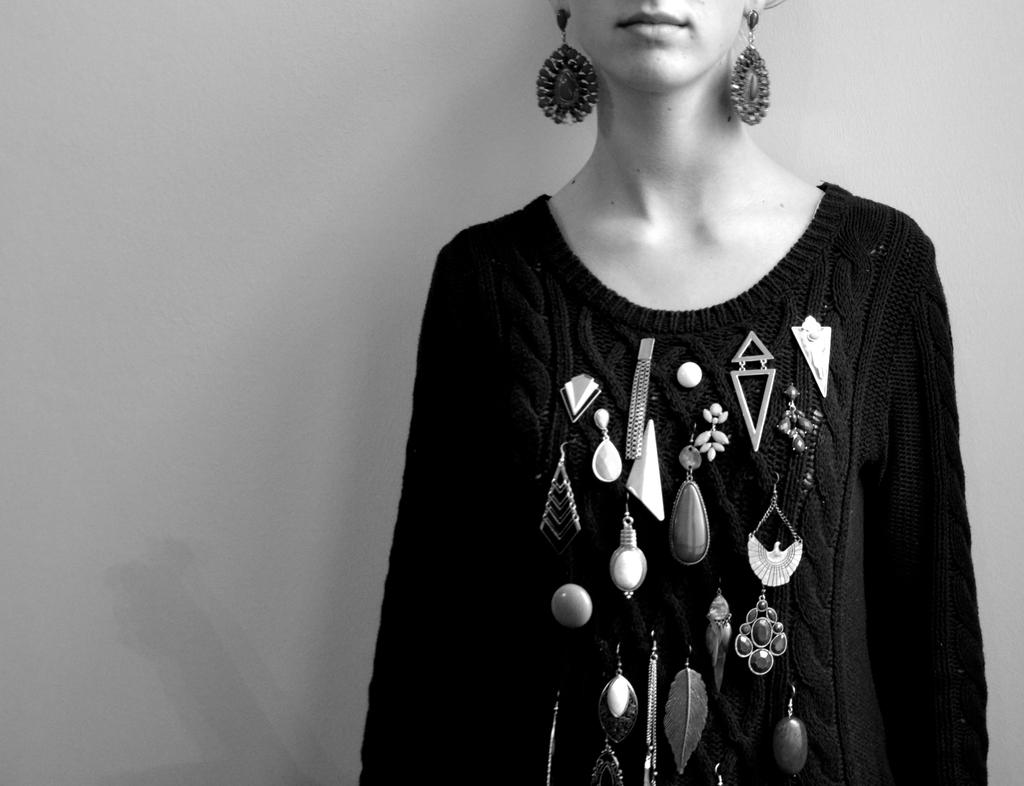What is the main subject of the image? There is a human in the image. What type of accessory is the human wearing? The human is wearing earrings. Are there any other earrings visible in the image? Yes, there are earrings depicted on the human's dress. What can be seen in the background of the image? There is a wall in the background of the image. What type of book is the human reading in the image? There is no book present in the image; the human is wearing earrings and has earrings depicted on their dress. What type of dolls can be seen playing with a machine in the image? There are no dolls or machines present in the image. 